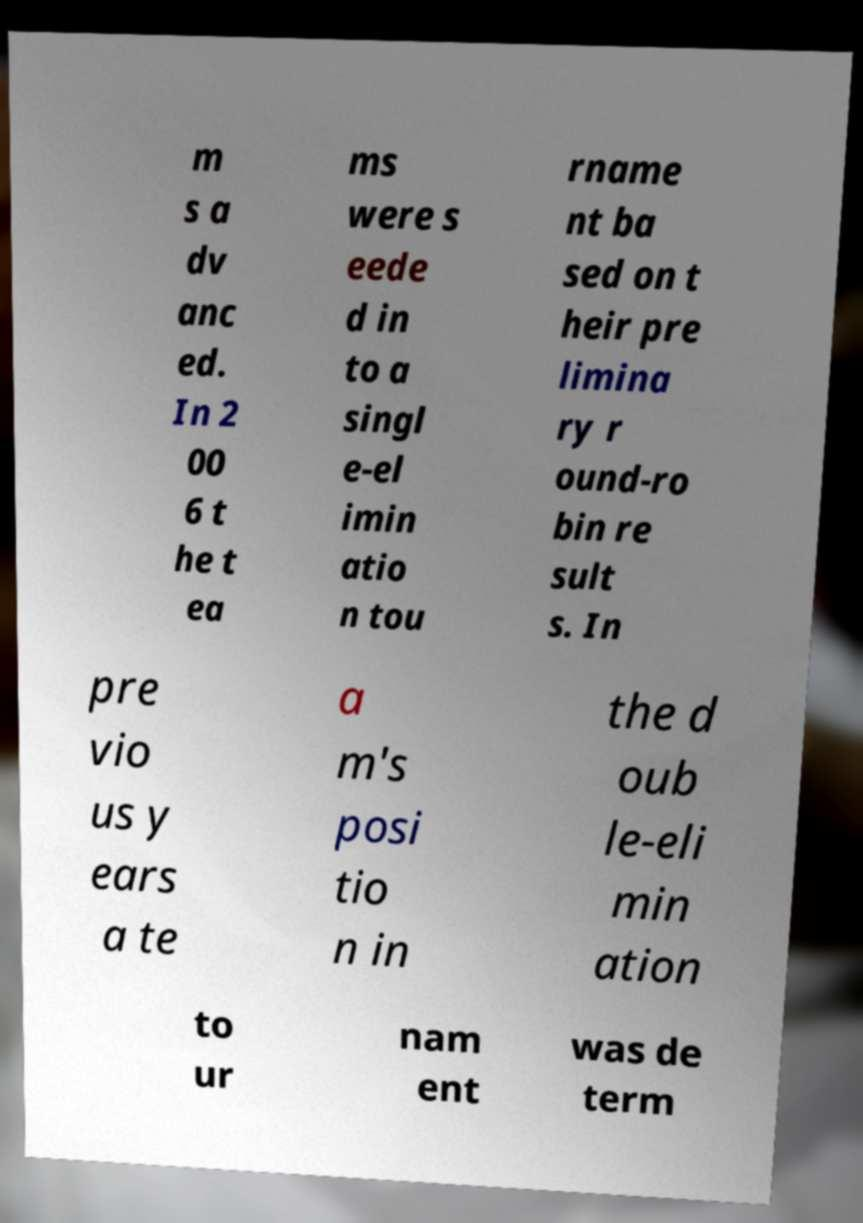Could you assist in decoding the text presented in this image and type it out clearly? m s a dv anc ed. In 2 00 6 t he t ea ms were s eede d in to a singl e-el imin atio n tou rname nt ba sed on t heir pre limina ry r ound-ro bin re sult s. In pre vio us y ears a te a m's posi tio n in the d oub le-eli min ation to ur nam ent was de term 